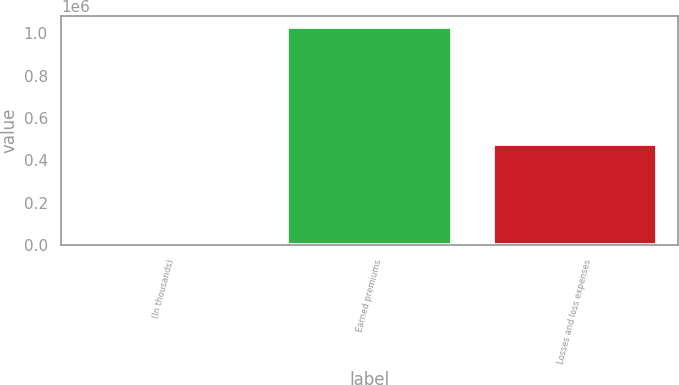Convert chart to OTSL. <chart><loc_0><loc_0><loc_500><loc_500><bar_chart><fcel>(In thousands)<fcel>Earned premiums<fcel>Losses and loss expenses<nl><fcel>2014<fcel>1.03067e+06<fcel>475802<nl></chart> 